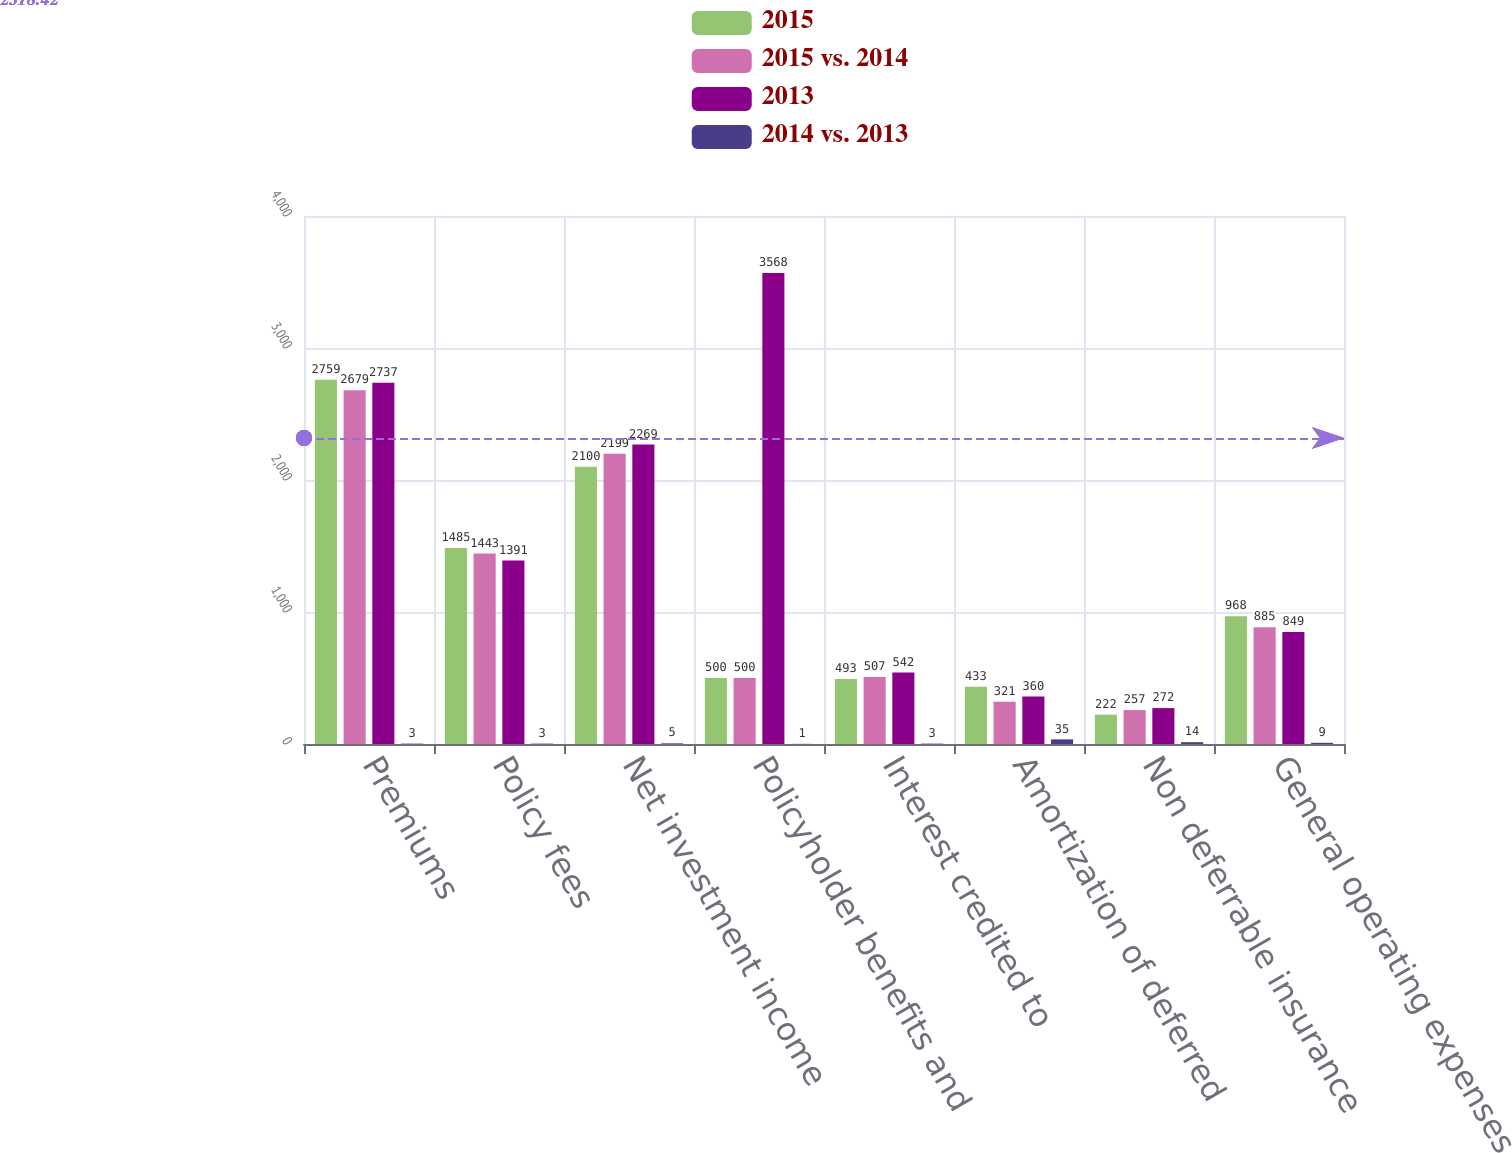Convert chart. <chart><loc_0><loc_0><loc_500><loc_500><stacked_bar_chart><ecel><fcel>Premiums<fcel>Policy fees<fcel>Net investment income<fcel>Policyholder benefits and<fcel>Interest credited to<fcel>Amortization of deferred<fcel>Non deferrable insurance<fcel>General operating expenses<nl><fcel>2015<fcel>2759<fcel>1485<fcel>2100<fcel>500<fcel>493<fcel>433<fcel>222<fcel>968<nl><fcel>2015 vs. 2014<fcel>2679<fcel>1443<fcel>2199<fcel>500<fcel>507<fcel>321<fcel>257<fcel>885<nl><fcel>2013<fcel>2737<fcel>1391<fcel>2269<fcel>3568<fcel>542<fcel>360<fcel>272<fcel>849<nl><fcel>2014 vs. 2013<fcel>3<fcel>3<fcel>5<fcel>1<fcel>3<fcel>35<fcel>14<fcel>9<nl></chart> 